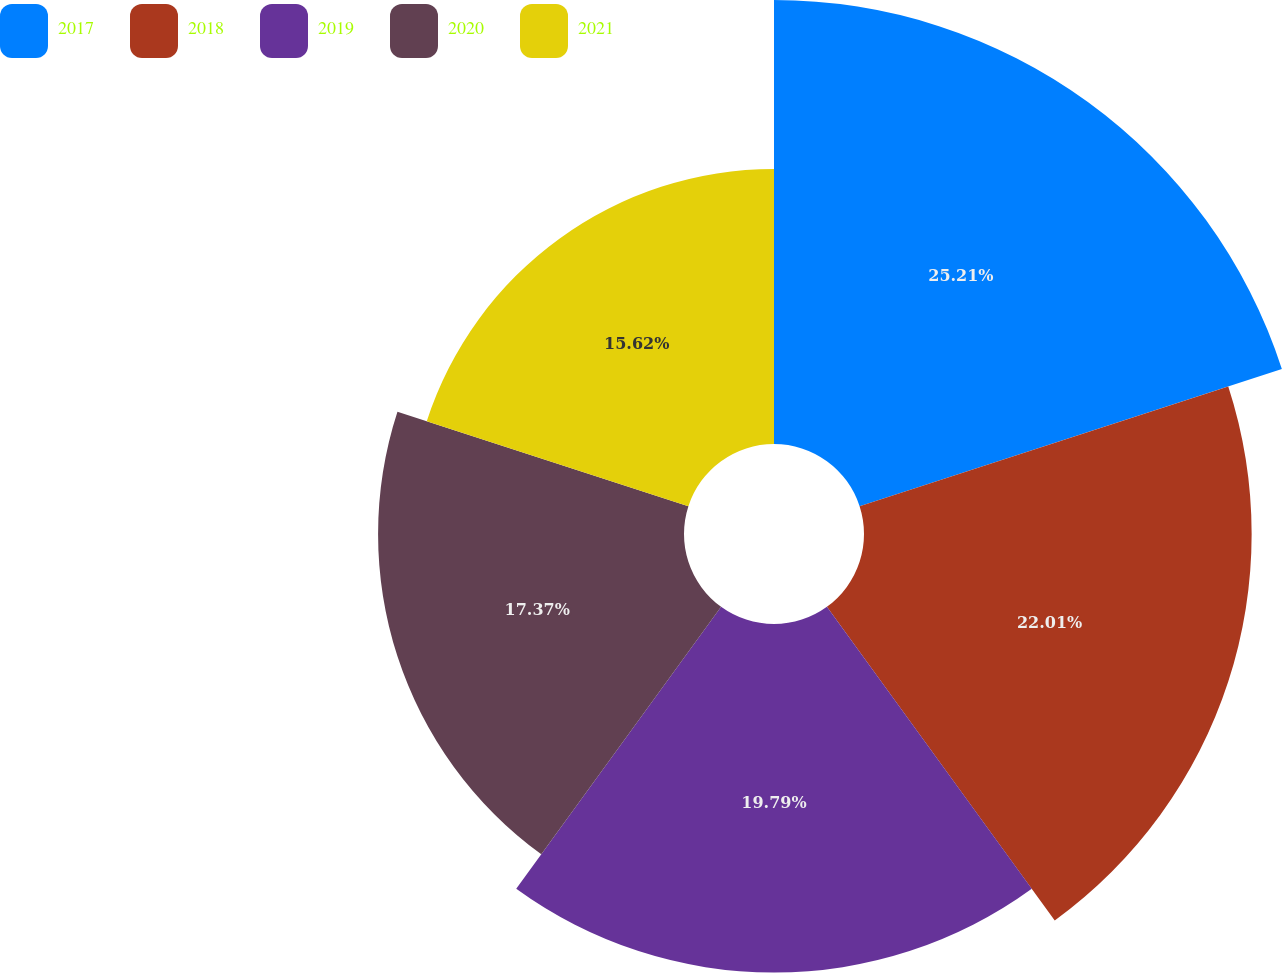Convert chart. <chart><loc_0><loc_0><loc_500><loc_500><pie_chart><fcel>2017<fcel>2018<fcel>2019<fcel>2020<fcel>2021<nl><fcel>25.21%<fcel>22.01%<fcel>19.79%<fcel>17.37%<fcel>15.62%<nl></chart> 